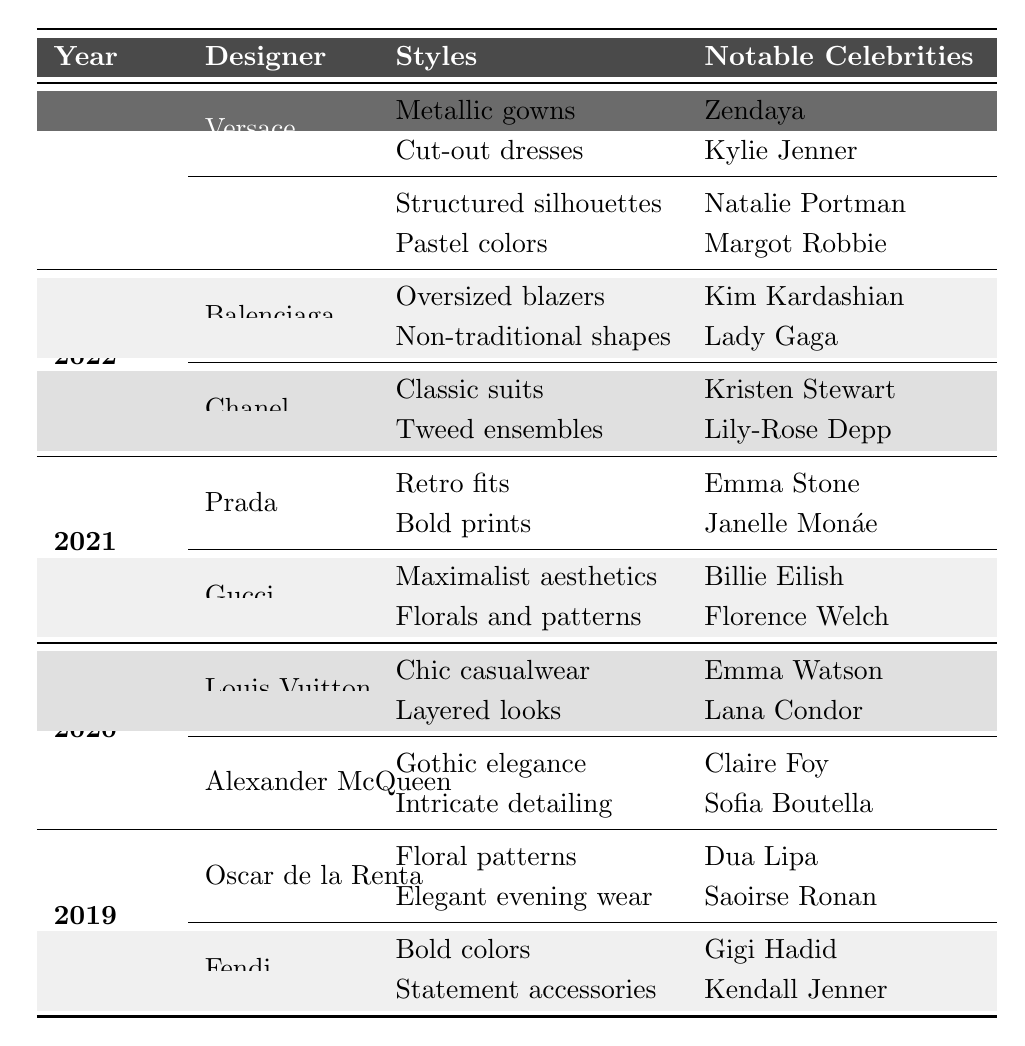What styles did Dior showcase in 2023? The table lists under the designer Dior for the year 2023 two styles: "Structured silhouettes" and "Pastel colors".
Answer: Structured silhouettes, Pastel colors Who wore designs from Balenciaga in 2022? From the table, under Balenciaga for 2022, the notable celebrities listed are "Kim Kardashian" and "Lady Gaga".
Answer: Kim Kardashian, Lady Gaga Which designer had Emma Stone as a notable celebrity in 2021? By reviewing the table for 2021, it shows that Emma Stone is associated with Prada.
Answer: Prada Did Gucci showcase bold prints in 2021? According to the table, under Gucci for 2021, one of the styles listed is "Bold prints", confirming the information.
Answer: Yes How many designers are listed for the year 2020? The table indicates there are two designers for the year 2020, specified as Louis Vuitton and Alexander McQueen.
Answer: 2 What is the total number of notable celebrities represented in the table for 2022? In 2022, there are four notable celebrities: Kim Kardashian, Lady Gaga, Kristen Stewart, and Lily-Rose Depp. Therefore, the total is 4.
Answer: 4 Which year featured "Metallic gowns" as a style? The entry for 2023 under Versace specifies "Metallic gowns" as one of its styles.
Answer: 2023 How many unique styles are mentioned for Fendi across the years? In the table, Fendi is listed only for 2019 with two unique styles: "Bold colors" and "Statement accessories", so there are 2 unique styles.
Answer: 2 Which celebrity from 2020 is noted for wearing designs from Alexander McQueen? The table shows that "Claire Foy" and "Sofia Boutella" are the notable celebrities associated with Alexander McQueen in 2020.
Answer: Claire Foy, Sofia Boutella 